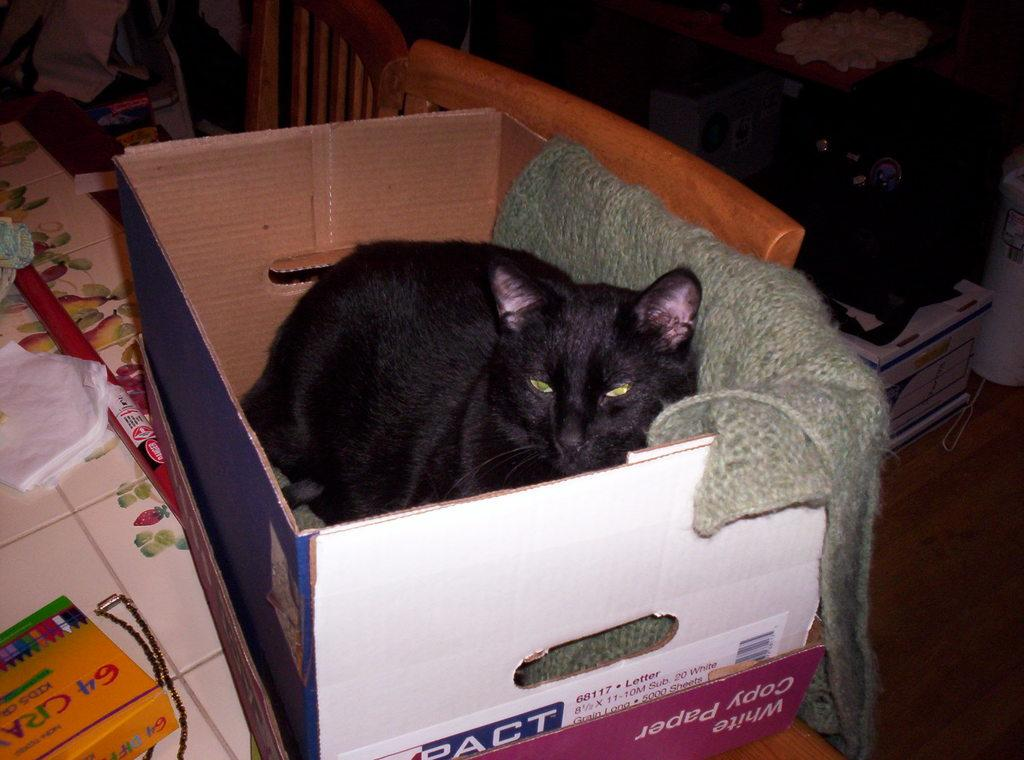<image>
Share a concise interpretation of the image provided. A black cat laying in a copy paper box. 